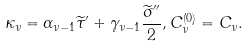<formula> <loc_0><loc_0><loc_500><loc_500>\kappa _ { \nu } = \alpha _ { \nu - 1 } \widetilde { \tau } ^ { \prime } + \gamma _ { \nu - 1 } \frac { \widetilde { \sigma } ^ { \prime \prime } } { 2 } , C _ { \nu } ^ { ( 0 ) } = C _ { \nu } .</formula> 